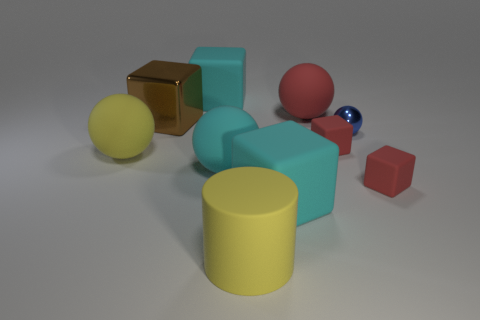What number of objects are either tiny red things behind the yellow matte ball or balls?
Provide a short and direct response. 5. What number of other objects are there of the same color as the cylinder?
Your response must be concise. 1. There is a small sphere; does it have the same color as the ball that is to the left of the large brown block?
Provide a short and direct response. No. There is another metal thing that is the same shape as the large red object; what is its color?
Give a very brief answer. Blue. Are the brown block and the sphere that is right of the large red matte object made of the same material?
Keep it short and to the point. Yes. What color is the tiny metallic object?
Provide a succinct answer. Blue. What color is the tiny shiny sphere on the right side of the yellow cylinder left of the large ball that is behind the tiny blue shiny ball?
Keep it short and to the point. Blue. Is the shape of the large brown thing the same as the big yellow object that is on the right side of the large metal block?
Ensure brevity in your answer.  No. The large matte ball that is both to the right of the brown metallic cube and behind the cyan sphere is what color?
Keep it short and to the point. Red. Are there any small brown things that have the same shape as the big metallic object?
Make the answer very short. No. 